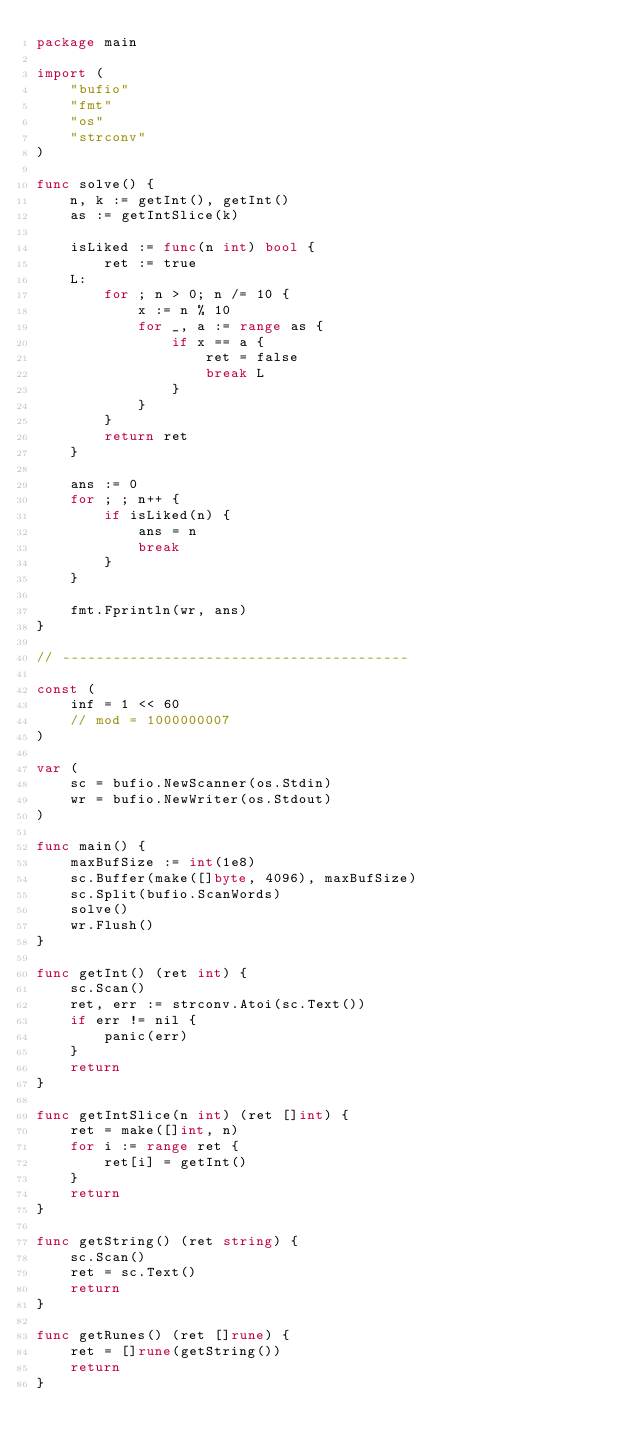<code> <loc_0><loc_0><loc_500><loc_500><_Go_>package main

import (
	"bufio"
	"fmt"
	"os"
	"strconv"
)

func solve() {
	n, k := getInt(), getInt()
	as := getIntSlice(k)

	isLiked := func(n int) bool {
		ret := true
	L:
		for ; n > 0; n /= 10 {
			x := n % 10
			for _, a := range as {
				if x == a {
					ret = false
					break L
				}
			}
		}
		return ret
	}

	ans := 0
	for ; ; n++ {
		if isLiked(n) {
			ans = n
			break
		}
	}

	fmt.Fprintln(wr, ans)
}

// -----------------------------------------

const (
	inf = 1 << 60
	// mod = 1000000007
)

var (
	sc = bufio.NewScanner(os.Stdin)
	wr = bufio.NewWriter(os.Stdout)
)

func main() {
	maxBufSize := int(1e8)
	sc.Buffer(make([]byte, 4096), maxBufSize)
	sc.Split(bufio.ScanWords)
	solve()
	wr.Flush()
}

func getInt() (ret int) {
	sc.Scan()
	ret, err := strconv.Atoi(sc.Text())
	if err != nil {
		panic(err)
	}
	return
}

func getIntSlice(n int) (ret []int) {
	ret = make([]int, n)
	for i := range ret {
		ret[i] = getInt()
	}
	return
}

func getString() (ret string) {
	sc.Scan()
	ret = sc.Text()
	return
}

func getRunes() (ret []rune) {
	ret = []rune(getString())
	return
}
</code> 